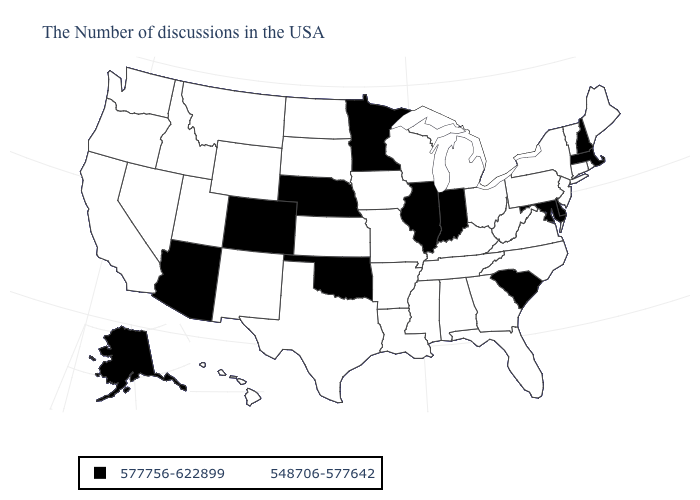Name the states that have a value in the range 548706-577642?
Be succinct. Maine, Rhode Island, Vermont, Connecticut, New York, New Jersey, Pennsylvania, Virginia, North Carolina, West Virginia, Ohio, Florida, Georgia, Michigan, Kentucky, Alabama, Tennessee, Wisconsin, Mississippi, Louisiana, Missouri, Arkansas, Iowa, Kansas, Texas, South Dakota, North Dakota, Wyoming, New Mexico, Utah, Montana, Idaho, Nevada, California, Washington, Oregon, Hawaii. Name the states that have a value in the range 548706-577642?
Quick response, please. Maine, Rhode Island, Vermont, Connecticut, New York, New Jersey, Pennsylvania, Virginia, North Carolina, West Virginia, Ohio, Florida, Georgia, Michigan, Kentucky, Alabama, Tennessee, Wisconsin, Mississippi, Louisiana, Missouri, Arkansas, Iowa, Kansas, Texas, South Dakota, North Dakota, Wyoming, New Mexico, Utah, Montana, Idaho, Nevada, California, Washington, Oregon, Hawaii. Name the states that have a value in the range 548706-577642?
Keep it brief. Maine, Rhode Island, Vermont, Connecticut, New York, New Jersey, Pennsylvania, Virginia, North Carolina, West Virginia, Ohio, Florida, Georgia, Michigan, Kentucky, Alabama, Tennessee, Wisconsin, Mississippi, Louisiana, Missouri, Arkansas, Iowa, Kansas, Texas, South Dakota, North Dakota, Wyoming, New Mexico, Utah, Montana, Idaho, Nevada, California, Washington, Oregon, Hawaii. Name the states that have a value in the range 548706-577642?
Concise answer only. Maine, Rhode Island, Vermont, Connecticut, New York, New Jersey, Pennsylvania, Virginia, North Carolina, West Virginia, Ohio, Florida, Georgia, Michigan, Kentucky, Alabama, Tennessee, Wisconsin, Mississippi, Louisiana, Missouri, Arkansas, Iowa, Kansas, Texas, South Dakota, North Dakota, Wyoming, New Mexico, Utah, Montana, Idaho, Nevada, California, Washington, Oregon, Hawaii. Does Maryland have the lowest value in the USA?
Be succinct. No. How many symbols are there in the legend?
Quick response, please. 2. What is the highest value in the USA?
Answer briefly. 577756-622899. Name the states that have a value in the range 577756-622899?
Keep it brief. Massachusetts, New Hampshire, Delaware, Maryland, South Carolina, Indiana, Illinois, Minnesota, Nebraska, Oklahoma, Colorado, Arizona, Alaska. Does Indiana have the highest value in the USA?
Be succinct. Yes. What is the value of Colorado?
Concise answer only. 577756-622899. Which states have the lowest value in the South?
Be succinct. Virginia, North Carolina, West Virginia, Florida, Georgia, Kentucky, Alabama, Tennessee, Mississippi, Louisiana, Arkansas, Texas. Does the first symbol in the legend represent the smallest category?
Concise answer only. No. What is the highest value in the Northeast ?
Quick response, please. 577756-622899. Does the map have missing data?
Quick response, please. No. Name the states that have a value in the range 548706-577642?
Answer briefly. Maine, Rhode Island, Vermont, Connecticut, New York, New Jersey, Pennsylvania, Virginia, North Carolina, West Virginia, Ohio, Florida, Georgia, Michigan, Kentucky, Alabama, Tennessee, Wisconsin, Mississippi, Louisiana, Missouri, Arkansas, Iowa, Kansas, Texas, South Dakota, North Dakota, Wyoming, New Mexico, Utah, Montana, Idaho, Nevada, California, Washington, Oregon, Hawaii. 